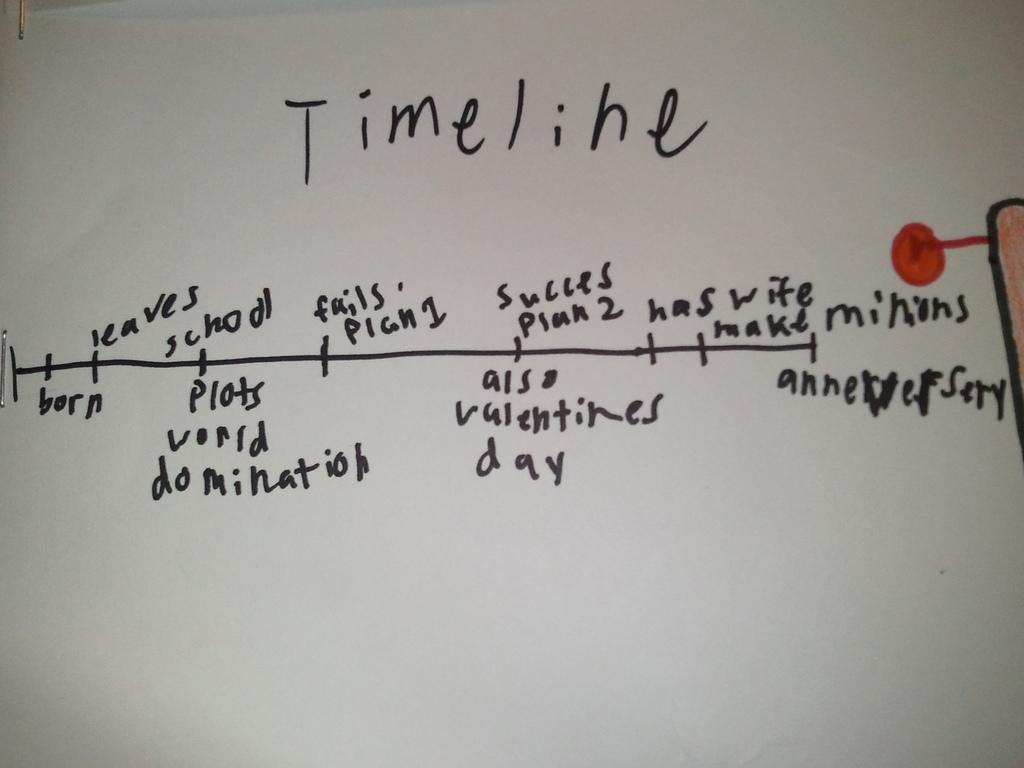What is the color of the main object in the image? The main object in the image is white. What is written on the white object? Something is written in black on the white object. Can you describe any other colors or features in the image? There is a red dot in the image. What type of drum is being played in the image? There is no drum present in the image; it only features a white object with something written in black and a red dot. 